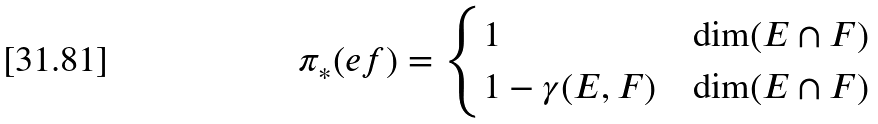Convert formula to latex. <formula><loc_0><loc_0><loc_500><loc_500>\pi _ { * } ( e f ) & = \begin{cases} 1 & \dim ( E \cap F ) \\ 1 - \gamma ( E , F ) & \dim ( E \cap F ) \end{cases}</formula> 